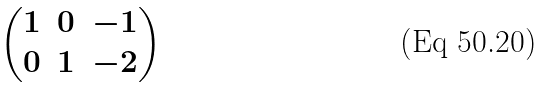<formula> <loc_0><loc_0><loc_500><loc_500>\begin{pmatrix} 1 & 0 & - 1 \\ 0 & 1 & - 2 \\ \end{pmatrix}</formula> 